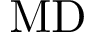Convert formula to latex. <formula><loc_0><loc_0><loc_500><loc_500>M D</formula> 